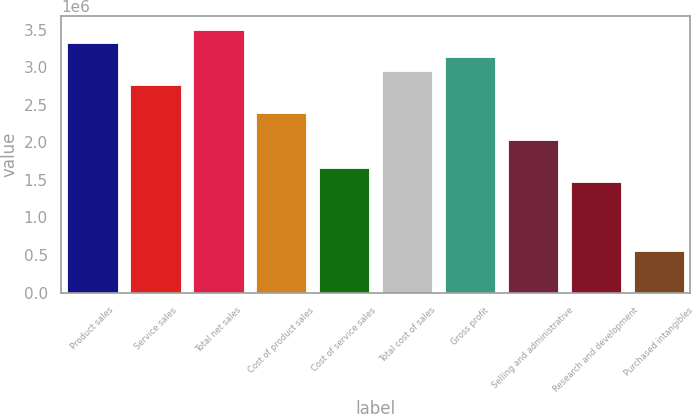Convert chart. <chart><loc_0><loc_0><loc_500><loc_500><bar_chart><fcel>Product sales<fcel>Service sales<fcel>Total net sales<fcel>Cost of product sales<fcel>Cost of service sales<fcel>Total cost of sales<fcel>Gross profit<fcel>Selling and administrative<fcel>Research and development<fcel>Purchased intangibles<nl><fcel>3.31855e+06<fcel>2.76546e+06<fcel>3.50291e+06<fcel>2.39673e+06<fcel>1.65928e+06<fcel>2.94982e+06<fcel>3.13419e+06<fcel>2.028e+06<fcel>1.47491e+06<fcel>553096<nl></chart> 